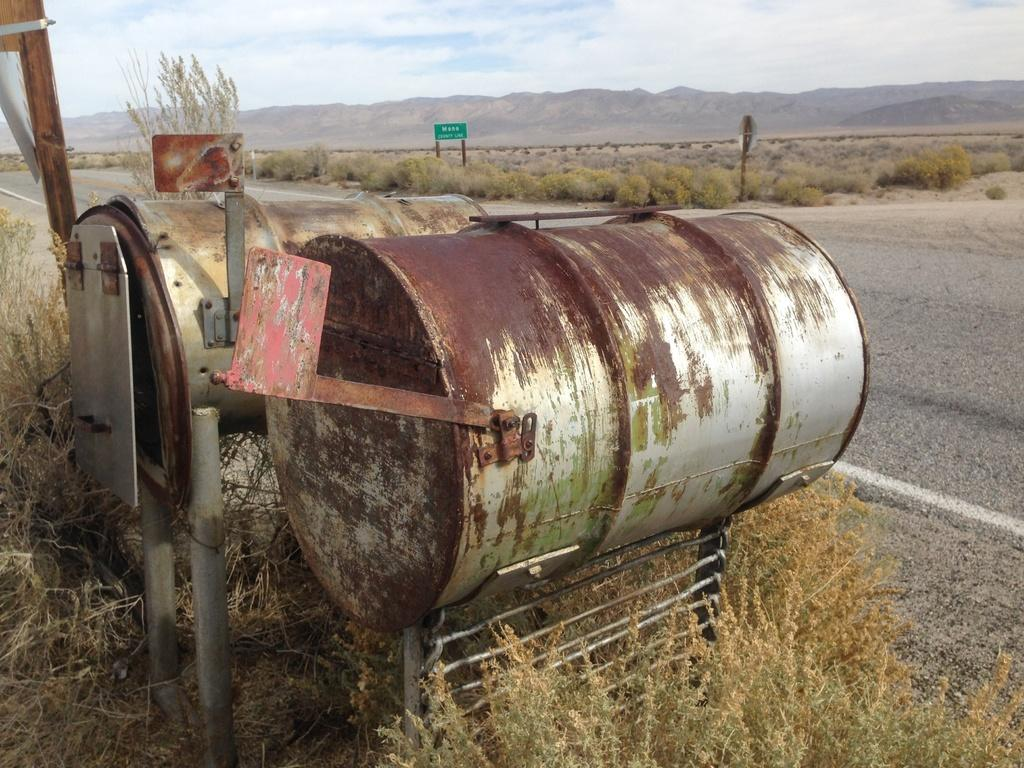What type of containers are present in the image? There are metal barrels in the image. What is written or displayed on a board in the image? There is a board with text in the image. What type of vegetation can be seen in the image? There are plants and a tree in the image. What type of landscape feature is present in the image? There is a hill in the image. How would you describe the sky in the image? The sky is blue and cloudy in the image. What type of spark can be seen coming from the business in the image? There is no business or spark present in the image. What type of print is visible on the plants in the image? There is no print on the plants in the image; they are natural vegetation. 